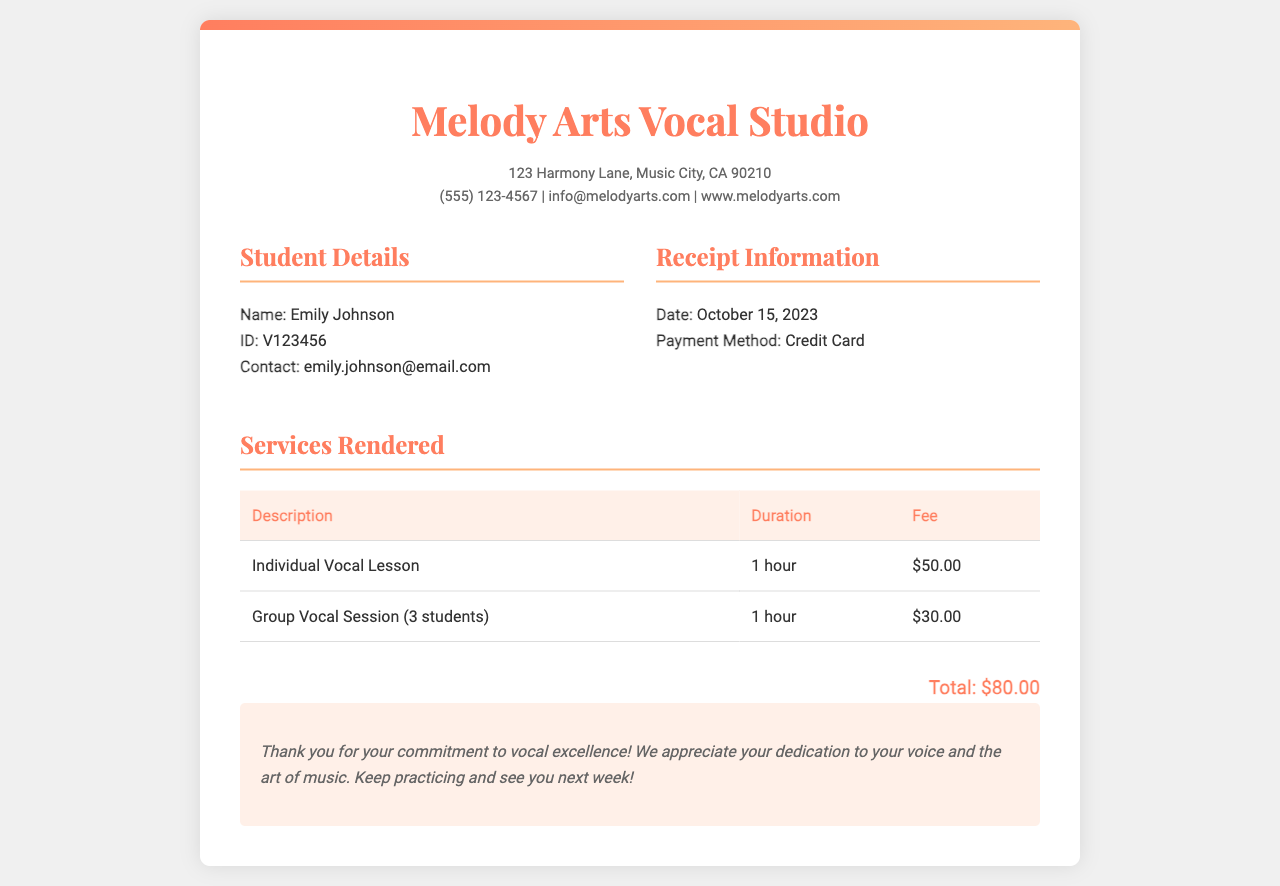What is the name of the vocal studio? The name of the vocal studio is displayed prominently at the top of the receipt.
Answer: Melody Arts Vocal Studio What is the date of the receipt? The date of the receipt is specified in the receipt information section.
Answer: October 15, 2023 How much is the fee for an individual vocal lesson? The fee for the individual vocal lesson is shown in the services rendered table.
Answer: $50.00 What is the duration of the group vocal session? The duration of the group vocal session is included in the services rendered table.
Answer: 1 hour What is Emily Johnson's student ID? The student ID is listed in the student details section of the receipt.
Answer: V123456 What payment method was used for this transaction? The payment method can be found in the receipt information section.
Answer: Credit Card What is the total amount paid for the lessons? The total amount is provided in the highlighted total section of the receipt.
Answer: $80.00 How many students are involved in the group vocal session? The number of students in the group session is mentioned in the description of the group vocal session.
Answer: 3 students What is included in the notes section of the receipt? The notes section expresses gratitude and encourages the student's dedication to practicing.
Answer: Thank you for your commitment to vocal excellence! 